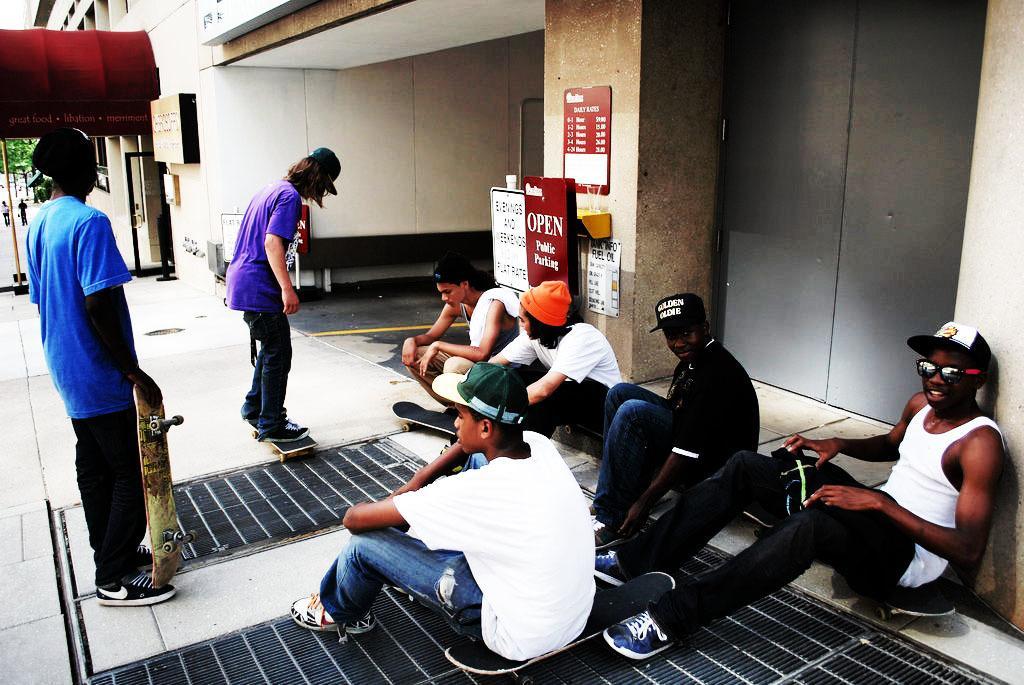Describe this image in one or two sentences. In this picture we can see five persons are sitting and two persons are standing, a person on the left side is holding a skateboard, in the background there is a building, we can see some boards on the right side, there is some text on these roads, we can also see a tree in the background. 